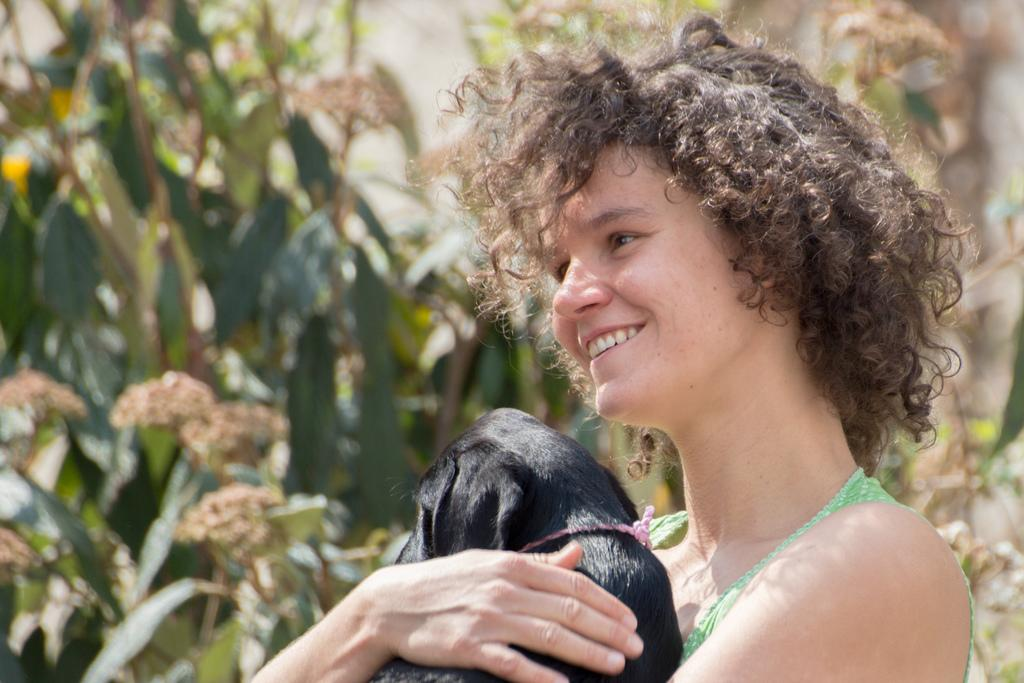Who is the main subject in the image? There is a lady in the image. What is the lady wearing? The lady is wearing a green top. What is the lady holding in her hand? The lady is holding an animal in her hand. What is the lady's facial expression? The lady is smiling. What can be seen in the background of the image? There are many plants in the background of the image. How would you describe the lady's hair? The lady has curly hair. What type of motion can be seen in the image? There is no motion visible in the image; it is a still photograph. 